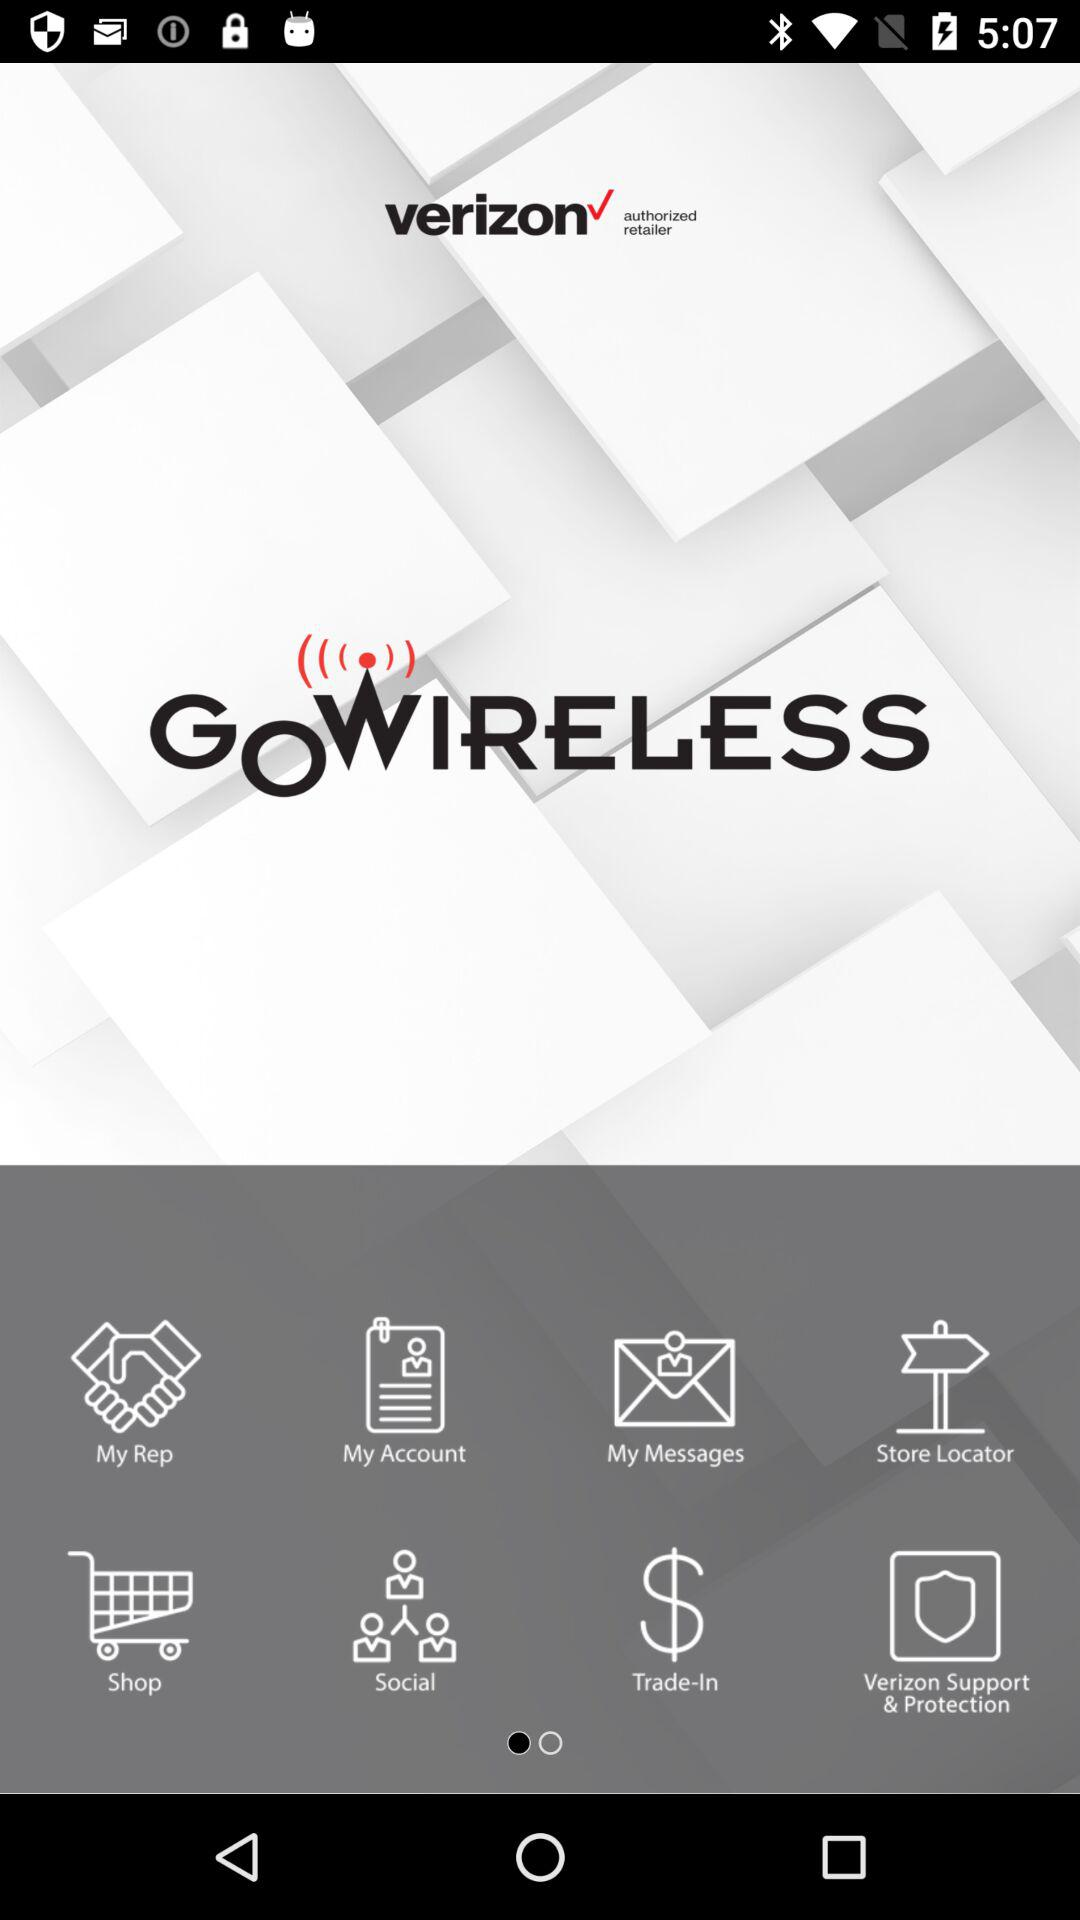What is the app name? The app name is "GOWIRELESS". 